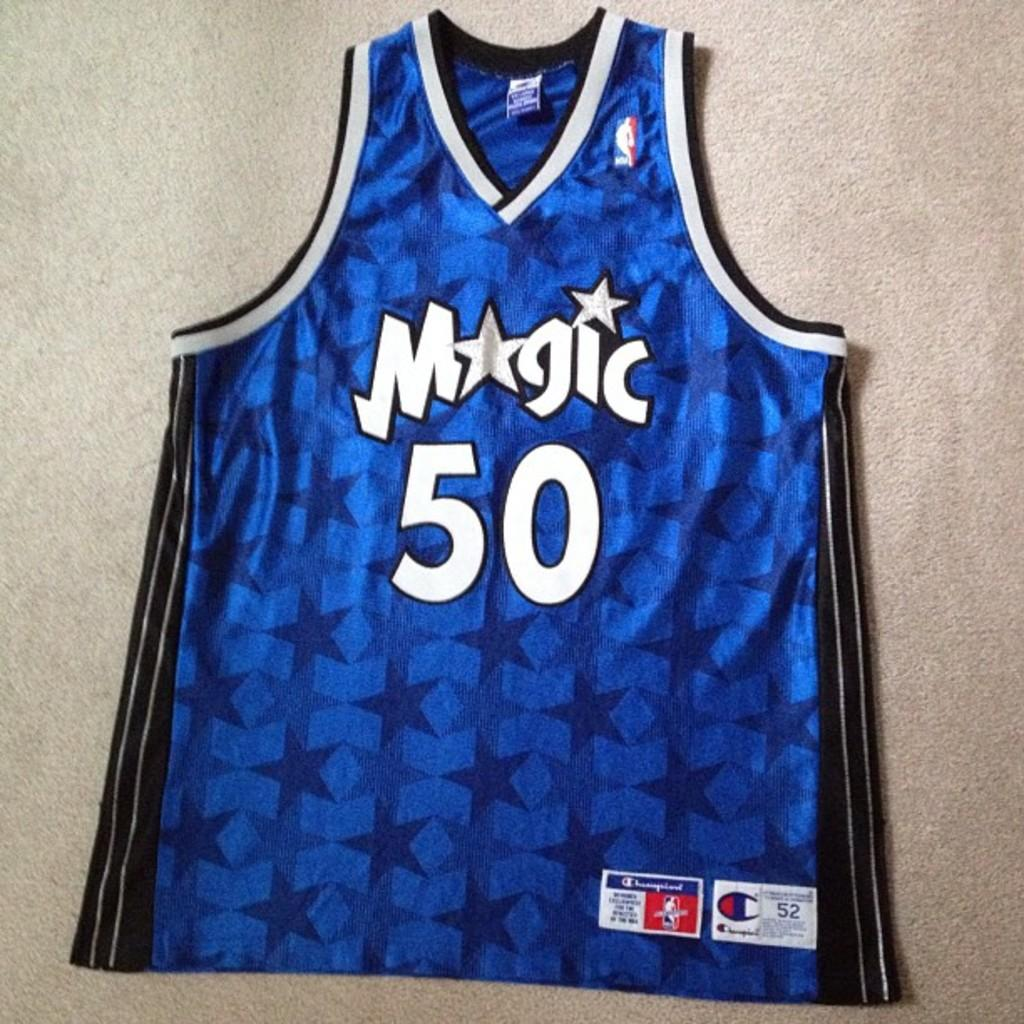<image>
Offer a succinct explanation of the picture presented. Blue magic jersey with the number fifty wrote on it 